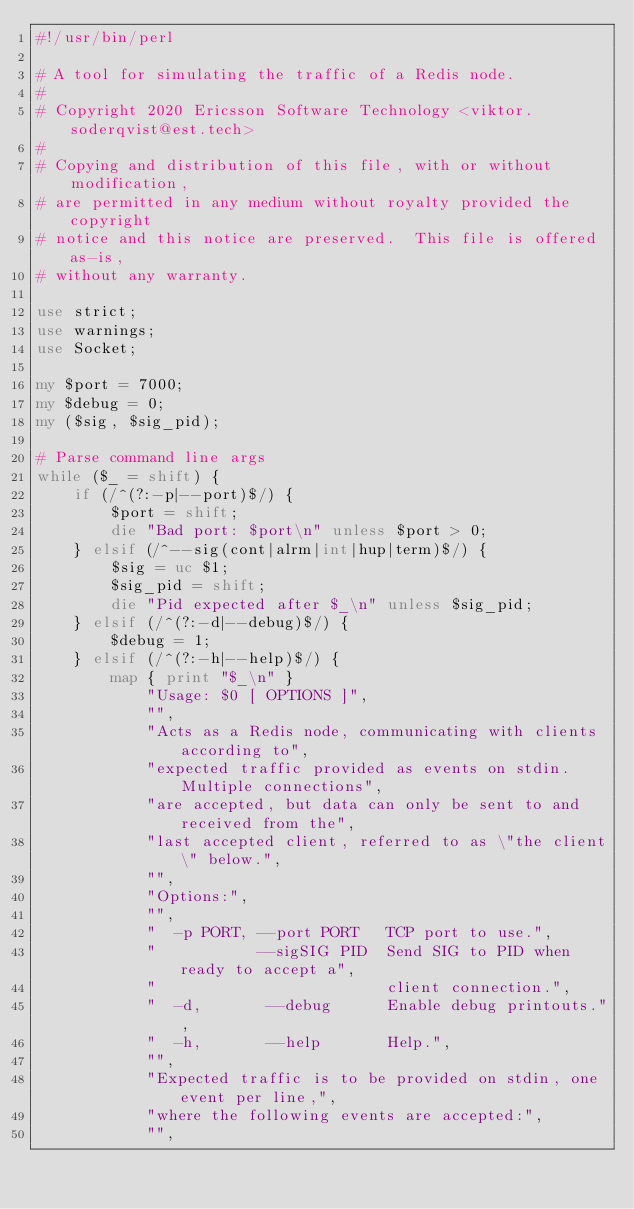Convert code to text. <code><loc_0><loc_0><loc_500><loc_500><_Perl_>#!/usr/bin/perl

# A tool for simulating the traffic of a Redis node.
#
# Copyright 2020 Ericsson Software Technology <viktor.soderqvist@est.tech>
#
# Copying and distribution of this file, with or without modification,
# are permitted in any medium without royalty provided the copyright
# notice and this notice are preserved.  This file is offered as-is,
# without any warranty.

use strict;
use warnings;
use Socket;

my $port = 7000;
my $debug = 0;
my ($sig, $sig_pid);

# Parse command line args
while ($_ = shift) {
    if (/^(?:-p|--port)$/) {
        $port = shift;
        die "Bad port: $port\n" unless $port > 0;
    } elsif (/^--sig(cont|alrm|int|hup|term)$/) {
        $sig = uc $1;
        $sig_pid = shift;
        die "Pid expected after $_\n" unless $sig_pid;
    } elsif (/^(?:-d|--debug)$/) {
        $debug = 1;
    } elsif (/^(?:-h|--help)$/) {
        map { print "$_\n" }
            "Usage: $0 [ OPTIONS ]",
            "",
            "Acts as a Redis node, communicating with clients according to",
            "expected traffic provided as events on stdin. Multiple connections",
            "are accepted, but data can only be sent to and received from the",
            "last accepted client, referred to as \"the client\" below.",
            "",
            "Options:",
            "",
            "  -p PORT, --port PORT   TCP port to use.",
            "           --sigSIG PID  Send SIG to PID when ready to accept a",
            "                         client connection.",
            "  -d,       --debug      Enable debug printouts.",
            "  -h,       --help       Help.",
            "",
            "Expected traffic is to be provided on stdin, one event per line,",
            "where the following events are accepted:",
            "",</code> 